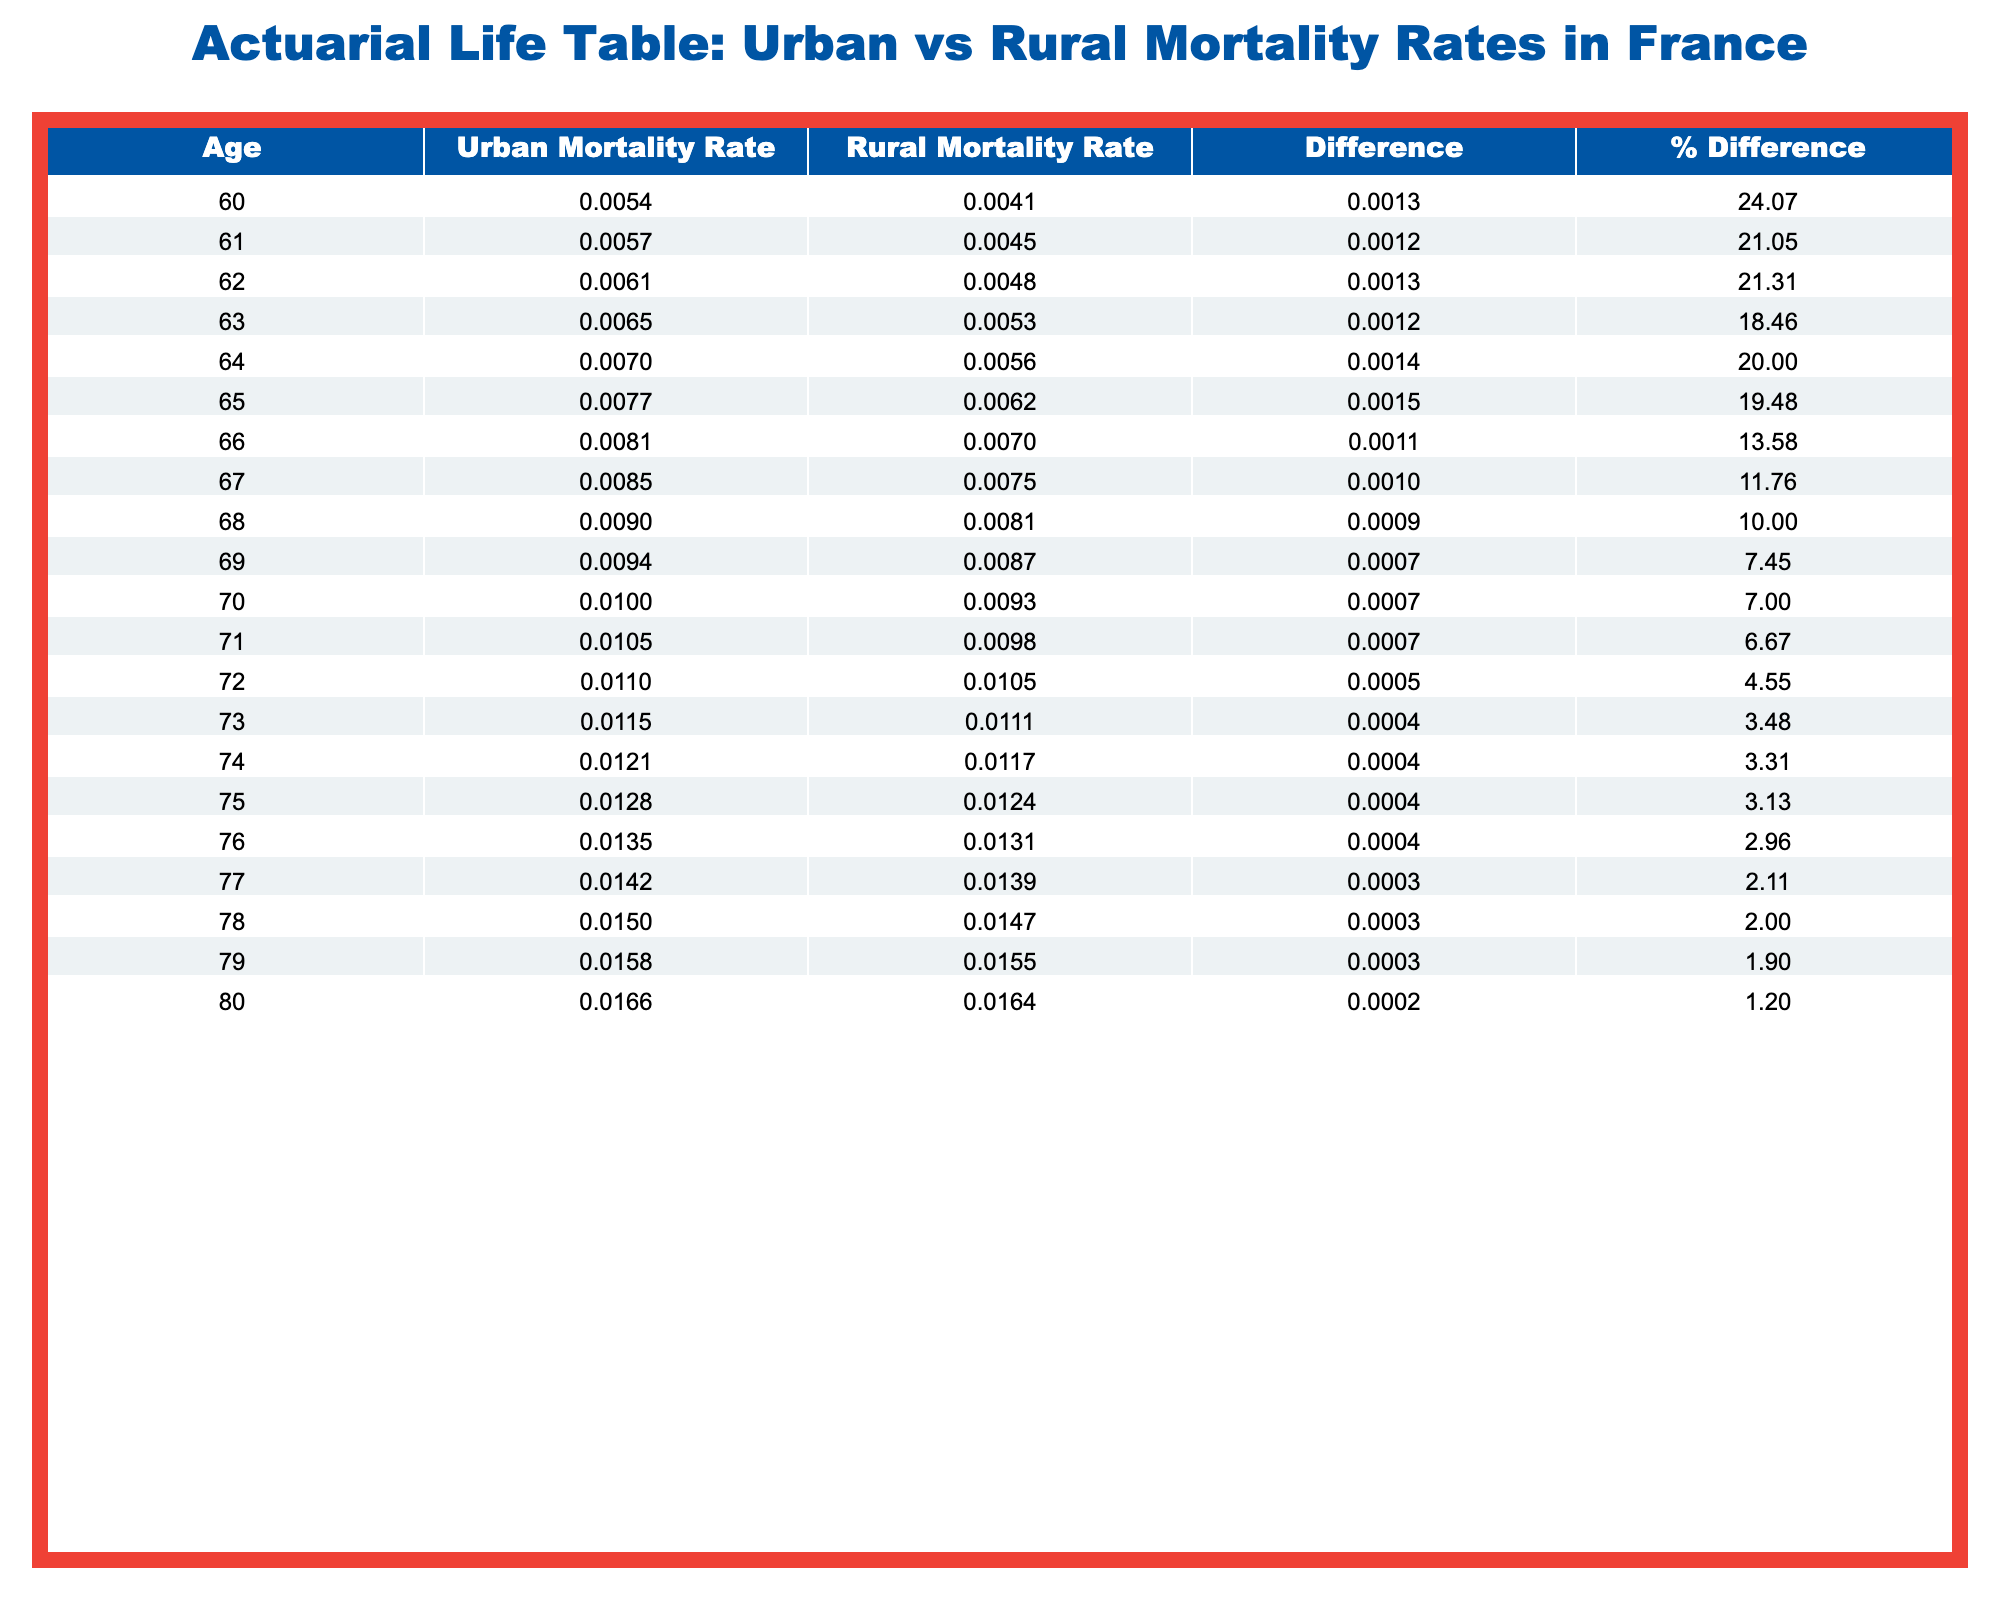What is the mortality rate for urban retirees at age 70? From the table, the Urban Mortality Rate for age 70 is listed directly under that age group. It is specifically noted as 0.0100.
Answer: 0.0100 What is the mortality rate for rural retirees at age 75? The table indicates that the Rural Mortality Rate for age 75 is provided directly, which is 0.0124.
Answer: 0.0124 At what age does the urban mortality rate surpass the rural mortality rate by more than 0.002? First, we compare the mortality rates across all ages. Starting from age 62, the differences between urban and rural rates exceed 0.002, for instance, the difference for age 62 is 0.0061 - 0.0048 = 0.0013, but at age 63, it is 0.0065 - 0.0053 = 0.0012, continuing until age 66 where the gap reaches 0.0011, and finally at age 67 it becomes 0.0085 - 0.0075 = 0.0010. Hence, age 62 is where the difference is first noted as significant.
Answer: 62 Is the rural mortality rate higher than the urban mortality rate for age 80? Looking at the table, for age 80, the Urban Mortality Rate is 0.0166 while the Rural Mortality Rate is 0.0164. Since 0.0164 is less than 0.0166, the rural rate is not higher than the urban.
Answer: No What is the average urban mortality rate for ages 60 to 65? To find the average, we sum the Urban Mortality Rates for ages 60, 61, 62, 63, 64, and 65: 0.0054 + 0.0057 + 0.0061 + 0.0065 + 0.0070 + 0.0077 = 0.0384. We then divide by the number of ages (6) to get the average rate: 0.0384 / 6 = 0.0064.
Answer: 0.0064 What is the percentage difference in mortality rates at age 76 between urban and rural retirees? The Urban Mortality Rate for age 76 is 0.0135 and the Rural Mortality Rate is 0.0131. The difference is calculated as 0.0135 - 0.0131 = 0.0004. To find the percentage difference we use the formula (difference / urban rate) * 100, which results in (0.0004 / 0.0135) * 100 = 2.96%, hence we can round it off to approximately 2.96%.
Answer: 2.96% 